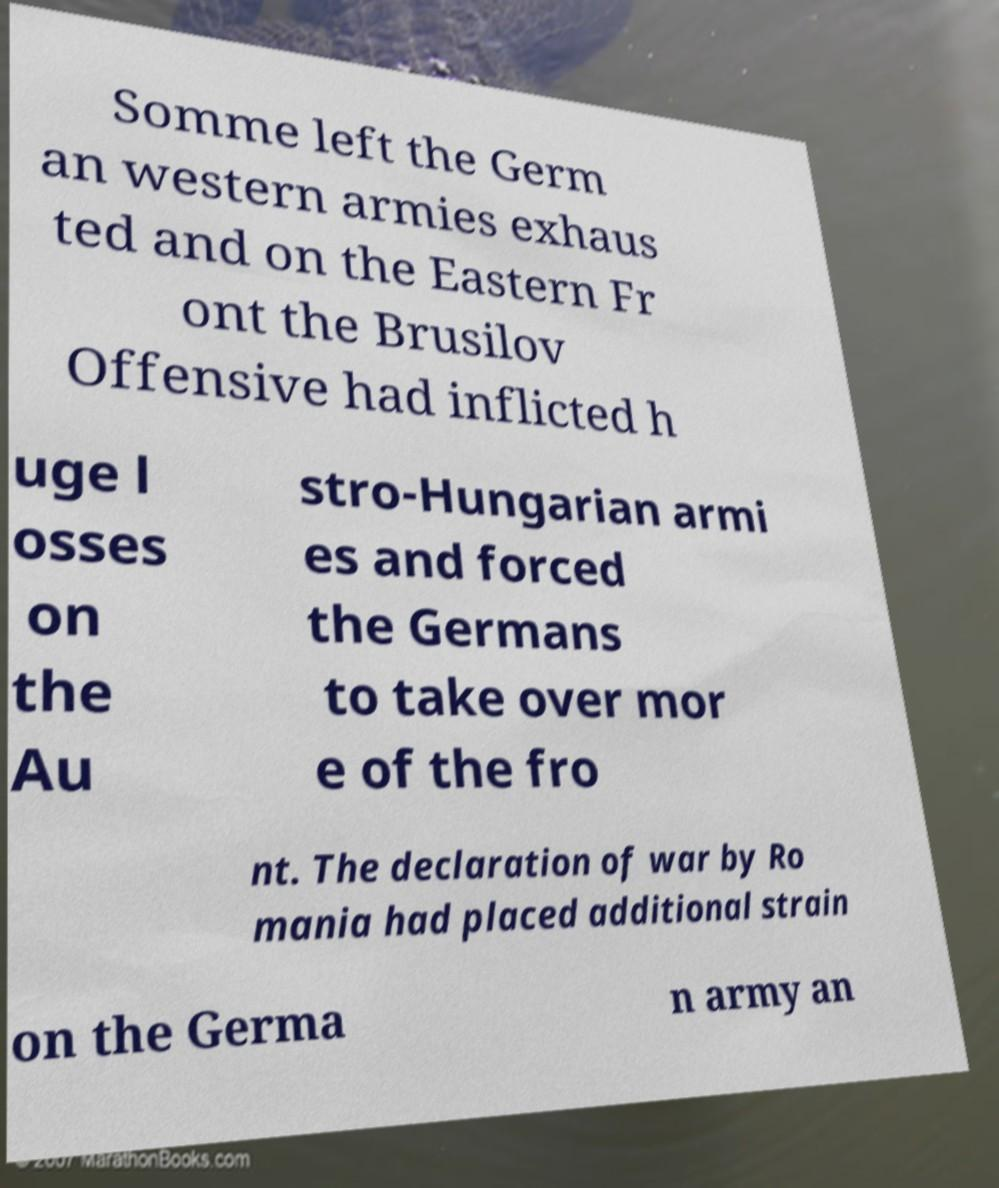Can you accurately transcribe the text from the provided image for me? Somme left the Germ an western armies exhaus ted and on the Eastern Fr ont the Brusilov Offensive had inflicted h uge l osses on the Au stro-Hungarian armi es and forced the Germans to take over mor e of the fro nt. The declaration of war by Ro mania had placed additional strain on the Germa n army an 